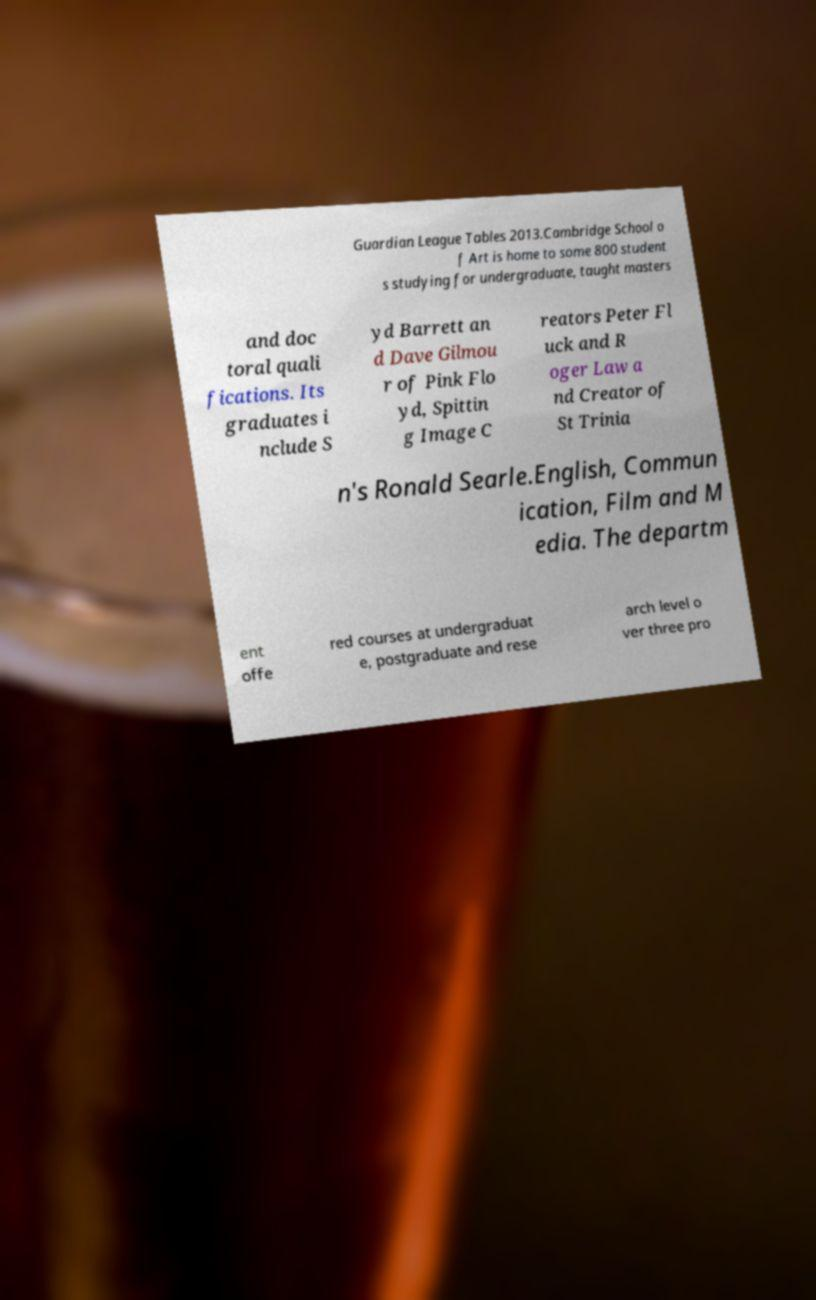Can you accurately transcribe the text from the provided image for me? Guardian League Tables 2013.Cambridge School o f Art is home to some 800 student s studying for undergraduate, taught masters and doc toral quali fications. Its graduates i nclude S yd Barrett an d Dave Gilmou r of Pink Flo yd, Spittin g Image C reators Peter Fl uck and R oger Law a nd Creator of St Trinia n's Ronald Searle.English, Commun ication, Film and M edia. The departm ent offe red courses at undergraduat e, postgraduate and rese arch level o ver three pro 